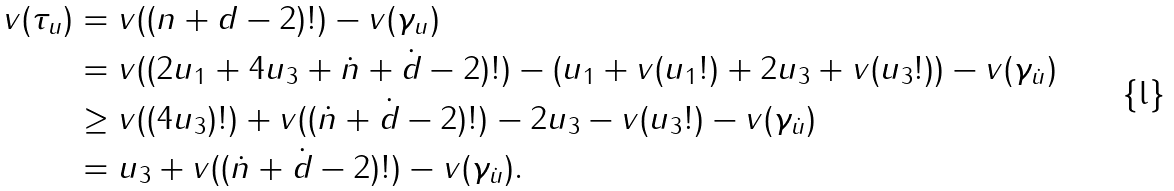<formula> <loc_0><loc_0><loc_500><loc_500>v ( \tau _ { u } ) & = v ( ( n + d - 2 ) ! ) - v ( \gamma _ { u } ) \\ & = v ( ( 2 u _ { 1 } + 4 u _ { 3 } + \dot { n } + \dot { d } - 2 ) ! ) - ( u _ { 1 } + v ( u _ { 1 } ! ) + 2 u _ { 3 } + v ( u _ { 3 } ! ) ) - v ( \gamma _ { \dot { u } } ) \\ & \geq v ( ( 4 u _ { 3 } ) ! ) + v ( ( \dot { n } + \dot { d } - 2 ) ! ) - 2 u _ { 3 } - v ( u _ { 3 } ! ) - v ( \gamma _ { \dot { u } } ) \\ & = u _ { 3 } + v ( ( \dot { n } + \dot { d } - 2 ) ! ) - v ( \gamma _ { \dot { u } } ) .</formula> 